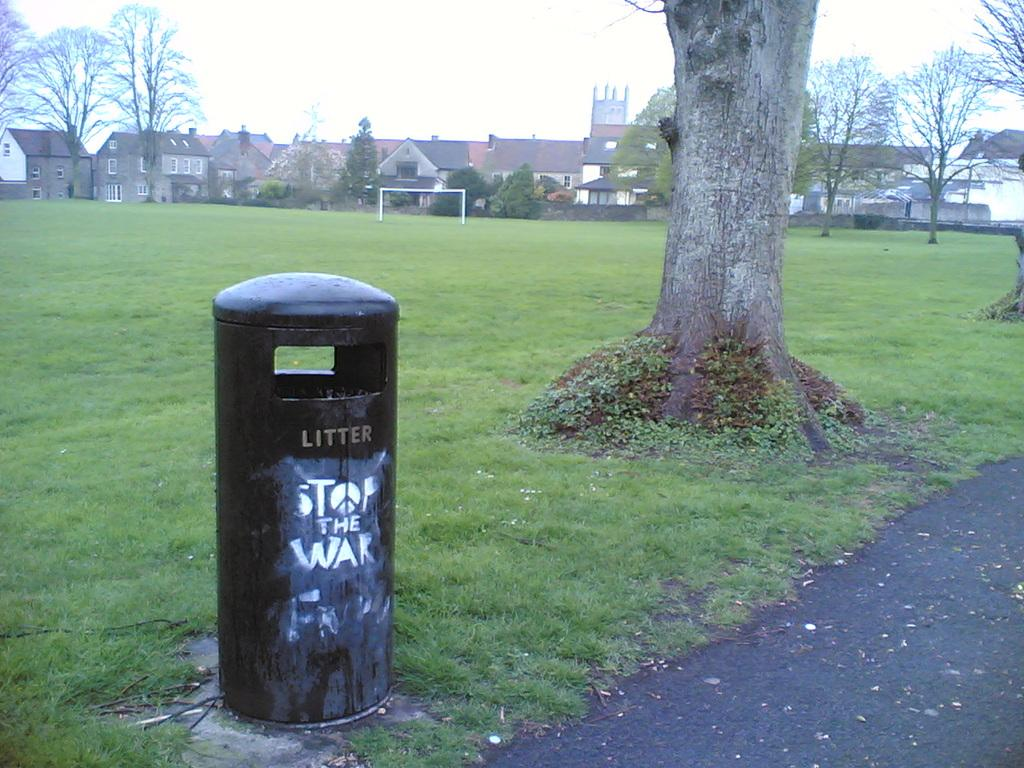<image>
Give a short and clear explanation of the subsequent image. A garbage pail has Stop the War painted on it. 